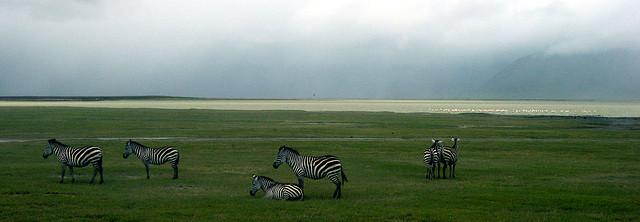What is on the grass?

Choices:
A) zebras
B) apples
C) cows
D) elephants zebras 